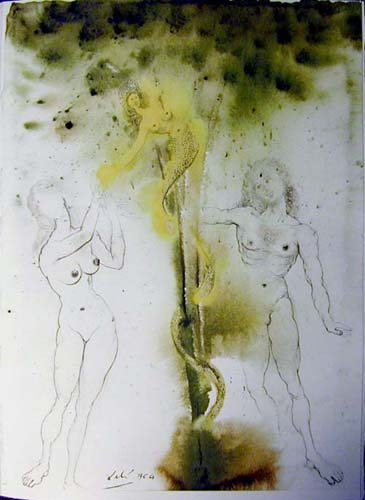What emotions do you think the artist was trying to convey through this artwork? The artist seems to be exploring themes of vulnerability and surrealism, evoking a sense of mystery and ambiguity. The nude figures, with their raw, unfinished lines suggest a raw exposure of human emotions, while the intertwining plant-like object could symbolize a connection to nature or each other, potentially representing growth, entanglement, or support. 